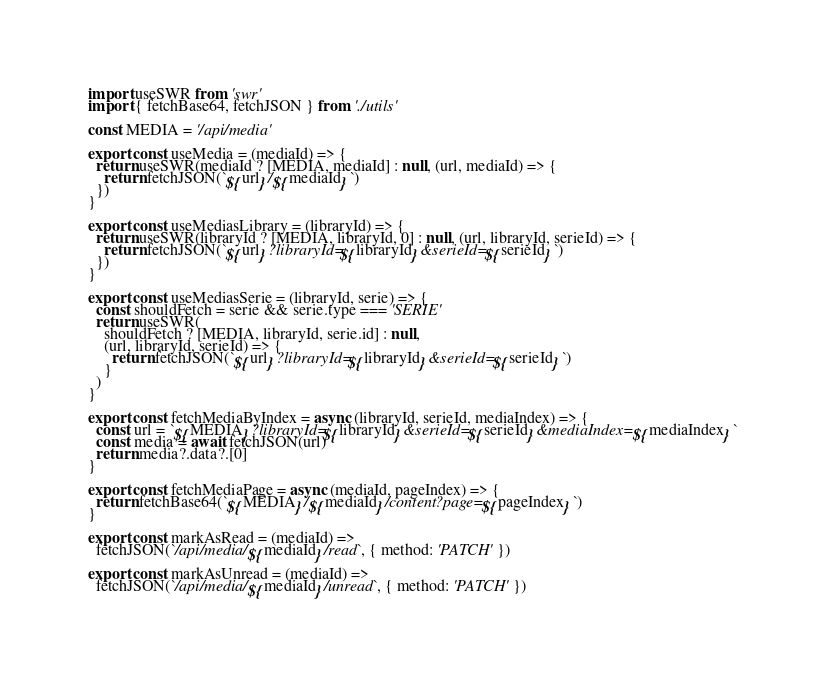<code> <loc_0><loc_0><loc_500><loc_500><_JavaScript_>import useSWR from 'swr'
import { fetchBase64, fetchJSON } from './utils'

const MEDIA = '/api/media'

export const useMedia = (mediaId) => {
  return useSWR(mediaId ? [MEDIA, mediaId] : null, (url, mediaId) => {
    return fetchJSON(`${url}/${mediaId}`)
  })
}

export const useMediasLibrary = (libraryId) => {
  return useSWR(libraryId ? [MEDIA, libraryId, 0] : null, (url, libraryId, serieId) => {
    return fetchJSON(`${url}?libraryId=${libraryId}&serieId=${serieId}`)
  })
}

export const useMediasSerie = (libraryId, serie) => {
  const shouldFetch = serie && serie.type === 'SERIE'
  return useSWR(
    shouldFetch ? [MEDIA, libraryId, serie.id] : null,
    (url, libraryId, serieId) => {
      return fetchJSON(`${url}?libraryId=${libraryId}&serieId=${serieId}`)
    }
  )
}

export const fetchMediaByIndex = async (libraryId, serieId, mediaIndex) => {
  const url = `${MEDIA}?libraryId=${libraryId}&serieId=${serieId}&mediaIndex=${mediaIndex}`
  const media = await fetchJSON(url)
  return media?.data?.[0]
}

export const fetchMediaPage = async (mediaId, pageIndex) => {
  return fetchBase64(`${MEDIA}/${mediaId}/content?page=${pageIndex}`)
}

export const markAsRead = (mediaId) =>
  fetchJSON(`/api/media/${mediaId}/read`, { method: 'PATCH' })

export const markAsUnread = (mediaId) =>
  fetchJSON(`/api/media/${mediaId}/unread`, { method: 'PATCH' })
</code> 